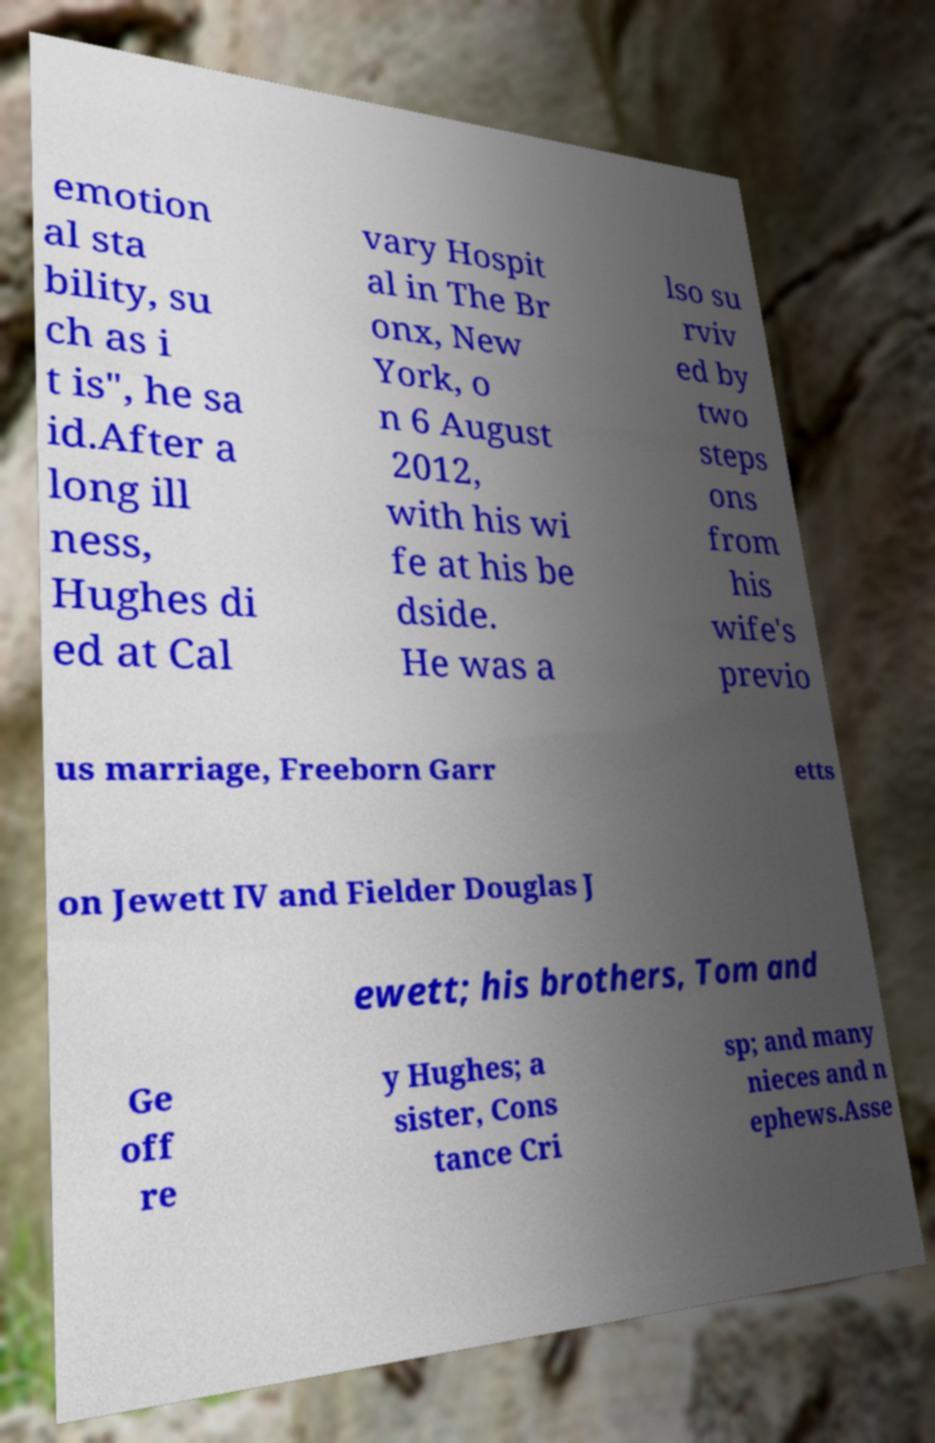Can you accurately transcribe the text from the provided image for me? emotion al sta bility, su ch as i t is", he sa id.After a long ill ness, Hughes di ed at Cal vary Hospit al in The Br onx, New York, o n 6 August 2012, with his wi fe at his be dside. He was a lso su rviv ed by two steps ons from his wife's previo us marriage, Freeborn Garr etts on Jewett IV and Fielder Douglas J ewett; his brothers, Tom and Ge off re y Hughes; a sister, Cons tance Cri sp; and many nieces and n ephews.Asse 